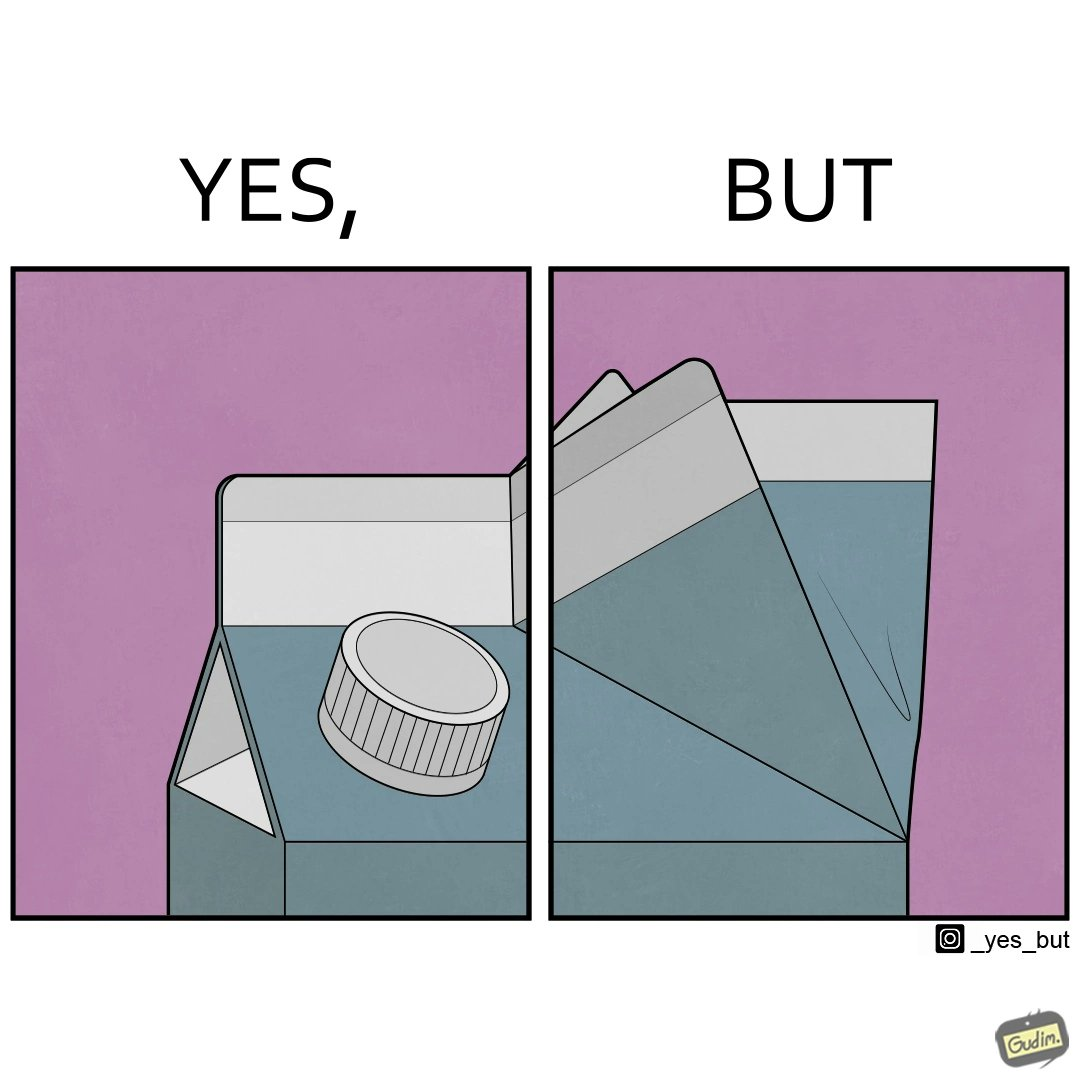Describe what you see in the left and right parts of this image. In the left part of the image: a lid or cap opening on a paper liquid container, probably tetra pack In the right part of the image: folded end of tetra pack 